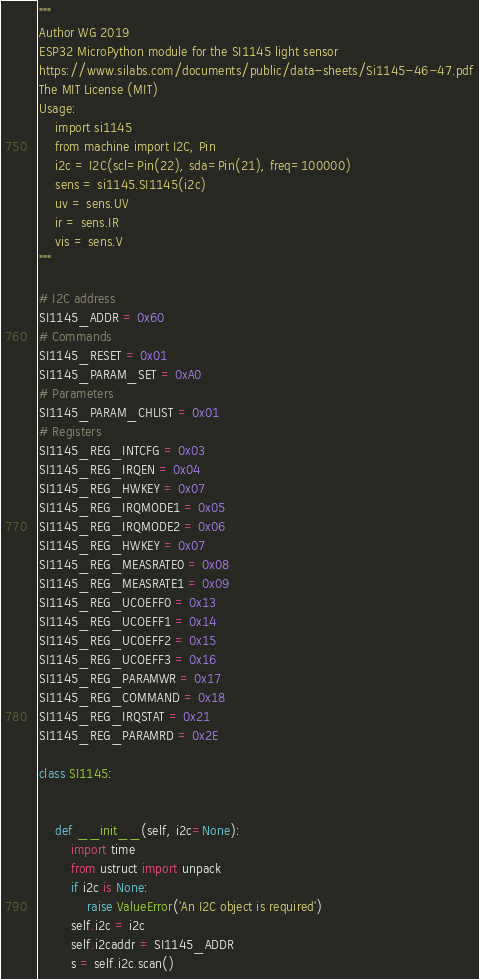Convert code to text. <code><loc_0><loc_0><loc_500><loc_500><_Python_>"""
Author WG 2019
ESP32 MicroPython module for the SI1145 light sensor
https://www.silabs.com/documents/public/data-sheets/Si1145-46-47.pdf
The MIT License (MIT)
Usage: 
    import si1145
    from machine import I2C, Pin
    i2c = I2C(scl=Pin(22), sda=Pin(21), freq=100000)
    sens = si1145.SI1145(i2c)
    uv = sens.UV
    ir = sens.IR
    vis = sens.V
"""

# I2C address
SI1145_ADDR = 0x60
# Commands
SI1145_RESET = 0x01
SI1145_PARAM_SET = 0xA0
# Parameters
SI1145_PARAM_CHLIST = 0x01
# Registers
SI1145_REG_INTCFG = 0x03
SI1145_REG_IRQEN = 0x04
SI1145_REG_HWKEY = 0x07
SI1145_REG_IRQMODE1 = 0x05
SI1145_REG_IRQMODE2 = 0x06
SI1145_REG_HWKEY = 0x07
SI1145_REG_MEASRATE0 = 0x08
SI1145_REG_MEASRATE1 = 0x09
SI1145_REG_UCOEFF0 = 0x13
SI1145_REG_UCOEFF1 = 0x14
SI1145_REG_UCOEFF2 = 0x15
SI1145_REG_UCOEFF3 = 0x16
SI1145_REG_PARAMWR = 0x17
SI1145_REG_COMMAND = 0x18
SI1145_REG_IRQSTAT = 0x21
SI1145_REG_PARAMRD = 0x2E

class SI1145:


    def __init__(self, i2c=None):
        import time
        from ustruct import unpack
        if i2c is None:
            raise ValueError('An I2C object is required')
        self.i2c = i2c
        self.i2caddr = SI1145_ADDR
        s = self.i2c.scan()</code> 